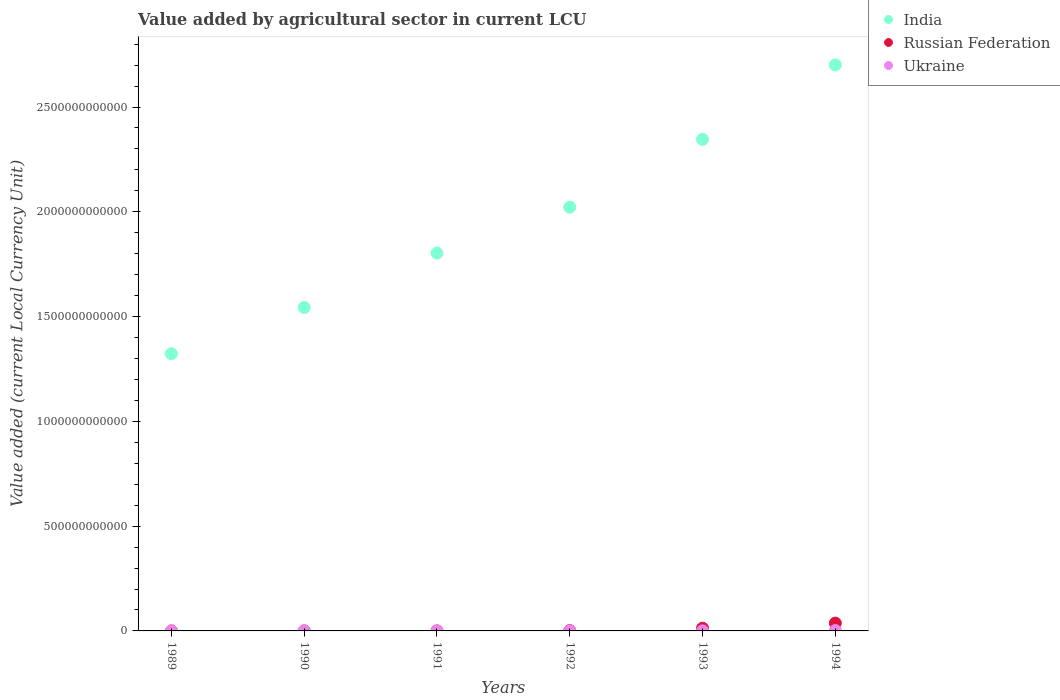Is the number of dotlines equal to the number of legend labels?
Provide a short and direct response. Yes. What is the value added by agricultural sector in Ukraine in 1994?
Give a very brief answer. 1.75e+09. Across all years, what is the maximum value added by agricultural sector in Ukraine?
Make the answer very short. 1.75e+09. Across all years, what is the minimum value added by agricultural sector in India?
Make the answer very short. 1.32e+12. In which year was the value added by agricultural sector in India minimum?
Give a very brief answer. 1989. What is the total value added by agricultural sector in Ukraine in the graph?
Your answer should be compact. 2.09e+09. What is the difference between the value added by agricultural sector in Ukraine in 1991 and that in 1992?
Give a very brief answer. -9.76e+06. What is the difference between the value added by agricultural sector in India in 1991 and the value added by agricultural sector in Ukraine in 1992?
Provide a short and direct response. 1.80e+12. What is the average value added by agricultural sector in Russian Federation per year?
Make the answer very short. 8.67e+09. In the year 1994, what is the difference between the value added by agricultural sector in Ukraine and value added by agricultural sector in India?
Give a very brief answer. -2.70e+12. In how many years, is the value added by agricultural sector in India greater than 1800000000000 LCU?
Your answer should be compact. 4. What is the ratio of the value added by agricultural sector in India in 1992 to that in 1994?
Make the answer very short. 0.75. Is the value added by agricultural sector in Ukraine in 1990 less than that in 1991?
Your response must be concise. Yes. What is the difference between the highest and the second highest value added by agricultural sector in Russian Federation?
Provide a succinct answer. 2.44e+1. What is the difference between the highest and the lowest value added by agricultural sector in India?
Your answer should be compact. 1.38e+12. Is it the case that in every year, the sum of the value added by agricultural sector in Ukraine and value added by agricultural sector in India  is greater than the value added by agricultural sector in Russian Federation?
Give a very brief answer. Yes. Does the value added by agricultural sector in Ukraine monotonically increase over the years?
Provide a succinct answer. Yes. How many years are there in the graph?
Ensure brevity in your answer.  6. What is the difference between two consecutive major ticks on the Y-axis?
Provide a short and direct response. 5.00e+11. Does the graph contain any zero values?
Your answer should be compact. No. Where does the legend appear in the graph?
Ensure brevity in your answer.  Top right. How are the legend labels stacked?
Make the answer very short. Vertical. What is the title of the graph?
Give a very brief answer. Value added by agricultural sector in current LCU. Does "Italy" appear as one of the legend labels in the graph?
Keep it short and to the point. No. What is the label or title of the X-axis?
Offer a very short reply. Years. What is the label or title of the Y-axis?
Keep it short and to the point. Value added (current Local Currency Unit). What is the Value added (current Local Currency Unit) in India in 1989?
Offer a terse response. 1.32e+12. What is the Value added (current Local Currency Unit) of Russian Federation in 1989?
Give a very brief answer. 8.94e+07. What is the Value added (current Local Currency Unit) of Ukraine in 1989?
Offer a terse response. 3.42e+05. What is the Value added (current Local Currency Unit) in India in 1990?
Your response must be concise. 1.54e+12. What is the Value added (current Local Currency Unit) in Russian Federation in 1990?
Offer a very short reply. 9.96e+07. What is the Value added (current Local Currency Unit) of Ukraine in 1990?
Offer a terse response. 4.09e+05. What is the Value added (current Local Currency Unit) in India in 1991?
Offer a terse response. 1.80e+12. What is the Value added (current Local Currency Unit) of Russian Federation in 1991?
Ensure brevity in your answer.  1.93e+08. What is the Value added (current Local Currency Unit) of Ukraine in 1991?
Your answer should be very brief. 7.37e+05. What is the Value added (current Local Currency Unit) of India in 1992?
Your response must be concise. 2.02e+12. What is the Value added (current Local Currency Unit) of Russian Federation in 1992?
Provide a short and direct response. 1.38e+09. What is the Value added (current Local Currency Unit) in Ukraine in 1992?
Make the answer very short. 1.05e+07. What is the Value added (current Local Currency Unit) of India in 1993?
Keep it short and to the point. 2.35e+12. What is the Value added (current Local Currency Unit) of Russian Federation in 1993?
Provide a succinct answer. 1.30e+1. What is the Value added (current Local Currency Unit) of Ukraine in 1993?
Your answer should be compact. 3.19e+08. What is the Value added (current Local Currency Unit) of India in 1994?
Make the answer very short. 2.70e+12. What is the Value added (current Local Currency Unit) of Russian Federation in 1994?
Offer a terse response. 3.73e+1. What is the Value added (current Local Currency Unit) in Ukraine in 1994?
Make the answer very short. 1.75e+09. Across all years, what is the maximum Value added (current Local Currency Unit) of India?
Give a very brief answer. 2.70e+12. Across all years, what is the maximum Value added (current Local Currency Unit) of Russian Federation?
Offer a terse response. 3.73e+1. Across all years, what is the maximum Value added (current Local Currency Unit) of Ukraine?
Your answer should be very brief. 1.75e+09. Across all years, what is the minimum Value added (current Local Currency Unit) in India?
Your response must be concise. 1.32e+12. Across all years, what is the minimum Value added (current Local Currency Unit) of Russian Federation?
Offer a very short reply. 8.94e+07. Across all years, what is the minimum Value added (current Local Currency Unit) in Ukraine?
Provide a succinct answer. 3.42e+05. What is the total Value added (current Local Currency Unit) of India in the graph?
Your answer should be very brief. 1.17e+13. What is the total Value added (current Local Currency Unit) of Russian Federation in the graph?
Offer a terse response. 5.20e+1. What is the total Value added (current Local Currency Unit) of Ukraine in the graph?
Your answer should be compact. 2.09e+09. What is the difference between the Value added (current Local Currency Unit) of India in 1989 and that in 1990?
Provide a succinct answer. -2.21e+11. What is the difference between the Value added (current Local Currency Unit) in Russian Federation in 1989 and that in 1990?
Your answer should be very brief. -1.02e+07. What is the difference between the Value added (current Local Currency Unit) in Ukraine in 1989 and that in 1990?
Make the answer very short. -6.71e+04. What is the difference between the Value added (current Local Currency Unit) of India in 1989 and that in 1991?
Make the answer very short. -4.80e+11. What is the difference between the Value added (current Local Currency Unit) of Russian Federation in 1989 and that in 1991?
Ensure brevity in your answer.  -1.03e+08. What is the difference between the Value added (current Local Currency Unit) in Ukraine in 1989 and that in 1991?
Provide a short and direct response. -3.96e+05. What is the difference between the Value added (current Local Currency Unit) of India in 1989 and that in 1992?
Keep it short and to the point. -7.00e+11. What is the difference between the Value added (current Local Currency Unit) of Russian Federation in 1989 and that in 1992?
Provide a short and direct response. -1.29e+09. What is the difference between the Value added (current Local Currency Unit) in Ukraine in 1989 and that in 1992?
Provide a succinct answer. -1.02e+07. What is the difference between the Value added (current Local Currency Unit) of India in 1989 and that in 1993?
Make the answer very short. -1.02e+12. What is the difference between the Value added (current Local Currency Unit) in Russian Federation in 1989 and that in 1993?
Make the answer very short. -1.29e+1. What is the difference between the Value added (current Local Currency Unit) in Ukraine in 1989 and that in 1993?
Provide a succinct answer. -3.19e+08. What is the difference between the Value added (current Local Currency Unit) of India in 1989 and that in 1994?
Provide a short and direct response. -1.38e+12. What is the difference between the Value added (current Local Currency Unit) in Russian Federation in 1989 and that in 1994?
Your answer should be compact. -3.72e+1. What is the difference between the Value added (current Local Currency Unit) in Ukraine in 1989 and that in 1994?
Your answer should be very brief. -1.75e+09. What is the difference between the Value added (current Local Currency Unit) in India in 1990 and that in 1991?
Provide a succinct answer. -2.60e+11. What is the difference between the Value added (current Local Currency Unit) of Russian Federation in 1990 and that in 1991?
Make the answer very short. -9.30e+07. What is the difference between the Value added (current Local Currency Unit) in Ukraine in 1990 and that in 1991?
Ensure brevity in your answer.  -3.28e+05. What is the difference between the Value added (current Local Currency Unit) of India in 1990 and that in 1992?
Your answer should be compact. -4.79e+11. What is the difference between the Value added (current Local Currency Unit) in Russian Federation in 1990 and that in 1992?
Make the answer very short. -1.28e+09. What is the difference between the Value added (current Local Currency Unit) of Ukraine in 1990 and that in 1992?
Give a very brief answer. -1.01e+07. What is the difference between the Value added (current Local Currency Unit) in India in 1990 and that in 1993?
Ensure brevity in your answer.  -8.02e+11. What is the difference between the Value added (current Local Currency Unit) of Russian Federation in 1990 and that in 1993?
Your answer should be very brief. -1.29e+1. What is the difference between the Value added (current Local Currency Unit) of Ukraine in 1990 and that in 1993?
Keep it short and to the point. -3.19e+08. What is the difference between the Value added (current Local Currency Unit) in India in 1990 and that in 1994?
Offer a terse response. -1.16e+12. What is the difference between the Value added (current Local Currency Unit) of Russian Federation in 1990 and that in 1994?
Keep it short and to the point. -3.72e+1. What is the difference between the Value added (current Local Currency Unit) of Ukraine in 1990 and that in 1994?
Your answer should be very brief. -1.75e+09. What is the difference between the Value added (current Local Currency Unit) in India in 1991 and that in 1992?
Your answer should be very brief. -2.19e+11. What is the difference between the Value added (current Local Currency Unit) of Russian Federation in 1991 and that in 1992?
Your response must be concise. -1.19e+09. What is the difference between the Value added (current Local Currency Unit) of Ukraine in 1991 and that in 1992?
Provide a short and direct response. -9.76e+06. What is the difference between the Value added (current Local Currency Unit) in India in 1991 and that in 1993?
Give a very brief answer. -5.43e+11. What is the difference between the Value added (current Local Currency Unit) in Russian Federation in 1991 and that in 1993?
Your response must be concise. -1.28e+1. What is the difference between the Value added (current Local Currency Unit) of Ukraine in 1991 and that in 1993?
Ensure brevity in your answer.  -3.19e+08. What is the difference between the Value added (current Local Currency Unit) of India in 1991 and that in 1994?
Your answer should be very brief. -8.98e+11. What is the difference between the Value added (current Local Currency Unit) in Russian Federation in 1991 and that in 1994?
Provide a succinct answer. -3.71e+1. What is the difference between the Value added (current Local Currency Unit) in Ukraine in 1991 and that in 1994?
Your response must be concise. -1.75e+09. What is the difference between the Value added (current Local Currency Unit) of India in 1992 and that in 1993?
Make the answer very short. -3.23e+11. What is the difference between the Value added (current Local Currency Unit) in Russian Federation in 1992 and that in 1993?
Provide a short and direct response. -1.16e+1. What is the difference between the Value added (current Local Currency Unit) of Ukraine in 1992 and that in 1993?
Offer a terse response. -3.09e+08. What is the difference between the Value added (current Local Currency Unit) of India in 1992 and that in 1994?
Make the answer very short. -6.79e+11. What is the difference between the Value added (current Local Currency Unit) of Russian Federation in 1992 and that in 1994?
Provide a short and direct response. -3.59e+1. What is the difference between the Value added (current Local Currency Unit) of Ukraine in 1992 and that in 1994?
Your response must be concise. -1.74e+09. What is the difference between the Value added (current Local Currency Unit) in India in 1993 and that in 1994?
Offer a very short reply. -3.55e+11. What is the difference between the Value added (current Local Currency Unit) of Russian Federation in 1993 and that in 1994?
Provide a short and direct response. -2.44e+1. What is the difference between the Value added (current Local Currency Unit) in Ukraine in 1993 and that in 1994?
Offer a very short reply. -1.43e+09. What is the difference between the Value added (current Local Currency Unit) of India in 1989 and the Value added (current Local Currency Unit) of Russian Federation in 1990?
Keep it short and to the point. 1.32e+12. What is the difference between the Value added (current Local Currency Unit) of India in 1989 and the Value added (current Local Currency Unit) of Ukraine in 1990?
Make the answer very short. 1.32e+12. What is the difference between the Value added (current Local Currency Unit) of Russian Federation in 1989 and the Value added (current Local Currency Unit) of Ukraine in 1990?
Your answer should be very brief. 8.90e+07. What is the difference between the Value added (current Local Currency Unit) of India in 1989 and the Value added (current Local Currency Unit) of Russian Federation in 1991?
Give a very brief answer. 1.32e+12. What is the difference between the Value added (current Local Currency Unit) in India in 1989 and the Value added (current Local Currency Unit) in Ukraine in 1991?
Provide a short and direct response. 1.32e+12. What is the difference between the Value added (current Local Currency Unit) of Russian Federation in 1989 and the Value added (current Local Currency Unit) of Ukraine in 1991?
Make the answer very short. 8.87e+07. What is the difference between the Value added (current Local Currency Unit) in India in 1989 and the Value added (current Local Currency Unit) in Russian Federation in 1992?
Provide a succinct answer. 1.32e+12. What is the difference between the Value added (current Local Currency Unit) of India in 1989 and the Value added (current Local Currency Unit) of Ukraine in 1992?
Your answer should be compact. 1.32e+12. What is the difference between the Value added (current Local Currency Unit) in Russian Federation in 1989 and the Value added (current Local Currency Unit) in Ukraine in 1992?
Offer a very short reply. 7.89e+07. What is the difference between the Value added (current Local Currency Unit) of India in 1989 and the Value added (current Local Currency Unit) of Russian Federation in 1993?
Your answer should be compact. 1.31e+12. What is the difference between the Value added (current Local Currency Unit) in India in 1989 and the Value added (current Local Currency Unit) in Ukraine in 1993?
Your response must be concise. 1.32e+12. What is the difference between the Value added (current Local Currency Unit) of Russian Federation in 1989 and the Value added (current Local Currency Unit) of Ukraine in 1993?
Provide a short and direct response. -2.30e+08. What is the difference between the Value added (current Local Currency Unit) in India in 1989 and the Value added (current Local Currency Unit) in Russian Federation in 1994?
Keep it short and to the point. 1.29e+12. What is the difference between the Value added (current Local Currency Unit) of India in 1989 and the Value added (current Local Currency Unit) of Ukraine in 1994?
Your answer should be compact. 1.32e+12. What is the difference between the Value added (current Local Currency Unit) of Russian Federation in 1989 and the Value added (current Local Currency Unit) of Ukraine in 1994?
Keep it short and to the point. -1.66e+09. What is the difference between the Value added (current Local Currency Unit) in India in 1990 and the Value added (current Local Currency Unit) in Russian Federation in 1991?
Offer a terse response. 1.54e+12. What is the difference between the Value added (current Local Currency Unit) in India in 1990 and the Value added (current Local Currency Unit) in Ukraine in 1991?
Offer a very short reply. 1.54e+12. What is the difference between the Value added (current Local Currency Unit) in Russian Federation in 1990 and the Value added (current Local Currency Unit) in Ukraine in 1991?
Offer a very short reply. 9.89e+07. What is the difference between the Value added (current Local Currency Unit) in India in 1990 and the Value added (current Local Currency Unit) in Russian Federation in 1992?
Provide a short and direct response. 1.54e+12. What is the difference between the Value added (current Local Currency Unit) in India in 1990 and the Value added (current Local Currency Unit) in Ukraine in 1992?
Offer a terse response. 1.54e+12. What is the difference between the Value added (current Local Currency Unit) of Russian Federation in 1990 and the Value added (current Local Currency Unit) of Ukraine in 1992?
Offer a terse response. 8.91e+07. What is the difference between the Value added (current Local Currency Unit) of India in 1990 and the Value added (current Local Currency Unit) of Russian Federation in 1993?
Your answer should be very brief. 1.53e+12. What is the difference between the Value added (current Local Currency Unit) of India in 1990 and the Value added (current Local Currency Unit) of Ukraine in 1993?
Keep it short and to the point. 1.54e+12. What is the difference between the Value added (current Local Currency Unit) in Russian Federation in 1990 and the Value added (current Local Currency Unit) in Ukraine in 1993?
Offer a terse response. -2.20e+08. What is the difference between the Value added (current Local Currency Unit) of India in 1990 and the Value added (current Local Currency Unit) of Russian Federation in 1994?
Offer a very short reply. 1.51e+12. What is the difference between the Value added (current Local Currency Unit) in India in 1990 and the Value added (current Local Currency Unit) in Ukraine in 1994?
Give a very brief answer. 1.54e+12. What is the difference between the Value added (current Local Currency Unit) in Russian Federation in 1990 and the Value added (current Local Currency Unit) in Ukraine in 1994?
Your answer should be very brief. -1.65e+09. What is the difference between the Value added (current Local Currency Unit) in India in 1991 and the Value added (current Local Currency Unit) in Russian Federation in 1992?
Your response must be concise. 1.80e+12. What is the difference between the Value added (current Local Currency Unit) of India in 1991 and the Value added (current Local Currency Unit) of Ukraine in 1992?
Provide a short and direct response. 1.80e+12. What is the difference between the Value added (current Local Currency Unit) of Russian Federation in 1991 and the Value added (current Local Currency Unit) of Ukraine in 1992?
Provide a short and direct response. 1.82e+08. What is the difference between the Value added (current Local Currency Unit) of India in 1991 and the Value added (current Local Currency Unit) of Russian Federation in 1993?
Ensure brevity in your answer.  1.79e+12. What is the difference between the Value added (current Local Currency Unit) of India in 1991 and the Value added (current Local Currency Unit) of Ukraine in 1993?
Make the answer very short. 1.80e+12. What is the difference between the Value added (current Local Currency Unit) of Russian Federation in 1991 and the Value added (current Local Currency Unit) of Ukraine in 1993?
Your answer should be very brief. -1.27e+08. What is the difference between the Value added (current Local Currency Unit) of India in 1991 and the Value added (current Local Currency Unit) of Russian Federation in 1994?
Give a very brief answer. 1.77e+12. What is the difference between the Value added (current Local Currency Unit) in India in 1991 and the Value added (current Local Currency Unit) in Ukraine in 1994?
Provide a succinct answer. 1.80e+12. What is the difference between the Value added (current Local Currency Unit) in Russian Federation in 1991 and the Value added (current Local Currency Unit) in Ukraine in 1994?
Make the answer very short. -1.56e+09. What is the difference between the Value added (current Local Currency Unit) of India in 1992 and the Value added (current Local Currency Unit) of Russian Federation in 1993?
Make the answer very short. 2.01e+12. What is the difference between the Value added (current Local Currency Unit) in India in 1992 and the Value added (current Local Currency Unit) in Ukraine in 1993?
Provide a succinct answer. 2.02e+12. What is the difference between the Value added (current Local Currency Unit) of Russian Federation in 1992 and the Value added (current Local Currency Unit) of Ukraine in 1993?
Keep it short and to the point. 1.06e+09. What is the difference between the Value added (current Local Currency Unit) of India in 1992 and the Value added (current Local Currency Unit) of Russian Federation in 1994?
Ensure brevity in your answer.  1.98e+12. What is the difference between the Value added (current Local Currency Unit) in India in 1992 and the Value added (current Local Currency Unit) in Ukraine in 1994?
Your response must be concise. 2.02e+12. What is the difference between the Value added (current Local Currency Unit) of Russian Federation in 1992 and the Value added (current Local Currency Unit) of Ukraine in 1994?
Your response must be concise. -3.73e+08. What is the difference between the Value added (current Local Currency Unit) of India in 1993 and the Value added (current Local Currency Unit) of Russian Federation in 1994?
Ensure brevity in your answer.  2.31e+12. What is the difference between the Value added (current Local Currency Unit) of India in 1993 and the Value added (current Local Currency Unit) of Ukraine in 1994?
Your response must be concise. 2.34e+12. What is the difference between the Value added (current Local Currency Unit) of Russian Federation in 1993 and the Value added (current Local Currency Unit) of Ukraine in 1994?
Offer a terse response. 1.12e+1. What is the average Value added (current Local Currency Unit) in India per year?
Your answer should be compact. 1.96e+12. What is the average Value added (current Local Currency Unit) in Russian Federation per year?
Keep it short and to the point. 8.67e+09. What is the average Value added (current Local Currency Unit) of Ukraine per year?
Offer a very short reply. 3.48e+08. In the year 1989, what is the difference between the Value added (current Local Currency Unit) of India and Value added (current Local Currency Unit) of Russian Federation?
Offer a very short reply. 1.32e+12. In the year 1989, what is the difference between the Value added (current Local Currency Unit) of India and Value added (current Local Currency Unit) of Ukraine?
Your answer should be very brief. 1.32e+12. In the year 1989, what is the difference between the Value added (current Local Currency Unit) in Russian Federation and Value added (current Local Currency Unit) in Ukraine?
Your answer should be compact. 8.91e+07. In the year 1990, what is the difference between the Value added (current Local Currency Unit) of India and Value added (current Local Currency Unit) of Russian Federation?
Give a very brief answer. 1.54e+12. In the year 1990, what is the difference between the Value added (current Local Currency Unit) in India and Value added (current Local Currency Unit) in Ukraine?
Offer a terse response. 1.54e+12. In the year 1990, what is the difference between the Value added (current Local Currency Unit) of Russian Federation and Value added (current Local Currency Unit) of Ukraine?
Make the answer very short. 9.92e+07. In the year 1991, what is the difference between the Value added (current Local Currency Unit) of India and Value added (current Local Currency Unit) of Russian Federation?
Your answer should be compact. 1.80e+12. In the year 1991, what is the difference between the Value added (current Local Currency Unit) in India and Value added (current Local Currency Unit) in Ukraine?
Offer a very short reply. 1.80e+12. In the year 1991, what is the difference between the Value added (current Local Currency Unit) of Russian Federation and Value added (current Local Currency Unit) of Ukraine?
Offer a very short reply. 1.92e+08. In the year 1992, what is the difference between the Value added (current Local Currency Unit) in India and Value added (current Local Currency Unit) in Russian Federation?
Provide a short and direct response. 2.02e+12. In the year 1992, what is the difference between the Value added (current Local Currency Unit) of India and Value added (current Local Currency Unit) of Ukraine?
Your answer should be compact. 2.02e+12. In the year 1992, what is the difference between the Value added (current Local Currency Unit) of Russian Federation and Value added (current Local Currency Unit) of Ukraine?
Offer a terse response. 1.37e+09. In the year 1993, what is the difference between the Value added (current Local Currency Unit) in India and Value added (current Local Currency Unit) in Russian Federation?
Offer a terse response. 2.33e+12. In the year 1993, what is the difference between the Value added (current Local Currency Unit) in India and Value added (current Local Currency Unit) in Ukraine?
Your response must be concise. 2.35e+12. In the year 1993, what is the difference between the Value added (current Local Currency Unit) in Russian Federation and Value added (current Local Currency Unit) in Ukraine?
Your response must be concise. 1.26e+1. In the year 1994, what is the difference between the Value added (current Local Currency Unit) of India and Value added (current Local Currency Unit) of Russian Federation?
Offer a very short reply. 2.66e+12. In the year 1994, what is the difference between the Value added (current Local Currency Unit) in India and Value added (current Local Currency Unit) in Ukraine?
Your answer should be very brief. 2.70e+12. In the year 1994, what is the difference between the Value added (current Local Currency Unit) in Russian Federation and Value added (current Local Currency Unit) in Ukraine?
Make the answer very short. 3.56e+1. What is the ratio of the Value added (current Local Currency Unit) of India in 1989 to that in 1990?
Offer a very short reply. 0.86. What is the ratio of the Value added (current Local Currency Unit) in Russian Federation in 1989 to that in 1990?
Provide a succinct answer. 0.9. What is the ratio of the Value added (current Local Currency Unit) of Ukraine in 1989 to that in 1990?
Provide a succinct answer. 0.84. What is the ratio of the Value added (current Local Currency Unit) in India in 1989 to that in 1991?
Your response must be concise. 0.73. What is the ratio of the Value added (current Local Currency Unit) of Russian Federation in 1989 to that in 1991?
Make the answer very short. 0.46. What is the ratio of the Value added (current Local Currency Unit) in Ukraine in 1989 to that in 1991?
Provide a succinct answer. 0.46. What is the ratio of the Value added (current Local Currency Unit) of India in 1989 to that in 1992?
Your answer should be very brief. 0.65. What is the ratio of the Value added (current Local Currency Unit) in Russian Federation in 1989 to that in 1992?
Ensure brevity in your answer.  0.06. What is the ratio of the Value added (current Local Currency Unit) in Ukraine in 1989 to that in 1992?
Your response must be concise. 0.03. What is the ratio of the Value added (current Local Currency Unit) in India in 1989 to that in 1993?
Keep it short and to the point. 0.56. What is the ratio of the Value added (current Local Currency Unit) in Russian Federation in 1989 to that in 1993?
Your answer should be very brief. 0.01. What is the ratio of the Value added (current Local Currency Unit) in Ukraine in 1989 to that in 1993?
Ensure brevity in your answer.  0. What is the ratio of the Value added (current Local Currency Unit) in India in 1989 to that in 1994?
Your response must be concise. 0.49. What is the ratio of the Value added (current Local Currency Unit) in Russian Federation in 1989 to that in 1994?
Provide a short and direct response. 0. What is the ratio of the Value added (current Local Currency Unit) in India in 1990 to that in 1991?
Provide a succinct answer. 0.86. What is the ratio of the Value added (current Local Currency Unit) of Russian Federation in 1990 to that in 1991?
Your response must be concise. 0.52. What is the ratio of the Value added (current Local Currency Unit) of Ukraine in 1990 to that in 1991?
Your response must be concise. 0.55. What is the ratio of the Value added (current Local Currency Unit) in India in 1990 to that in 1992?
Keep it short and to the point. 0.76. What is the ratio of the Value added (current Local Currency Unit) of Russian Federation in 1990 to that in 1992?
Ensure brevity in your answer.  0.07. What is the ratio of the Value added (current Local Currency Unit) in Ukraine in 1990 to that in 1992?
Ensure brevity in your answer.  0.04. What is the ratio of the Value added (current Local Currency Unit) in India in 1990 to that in 1993?
Your response must be concise. 0.66. What is the ratio of the Value added (current Local Currency Unit) of Russian Federation in 1990 to that in 1993?
Your answer should be very brief. 0.01. What is the ratio of the Value added (current Local Currency Unit) of Ukraine in 1990 to that in 1993?
Make the answer very short. 0. What is the ratio of the Value added (current Local Currency Unit) of India in 1990 to that in 1994?
Your answer should be compact. 0.57. What is the ratio of the Value added (current Local Currency Unit) of Russian Federation in 1990 to that in 1994?
Give a very brief answer. 0. What is the ratio of the Value added (current Local Currency Unit) in Ukraine in 1990 to that in 1994?
Provide a short and direct response. 0. What is the ratio of the Value added (current Local Currency Unit) in India in 1991 to that in 1992?
Your response must be concise. 0.89. What is the ratio of the Value added (current Local Currency Unit) in Russian Federation in 1991 to that in 1992?
Your response must be concise. 0.14. What is the ratio of the Value added (current Local Currency Unit) in Ukraine in 1991 to that in 1992?
Provide a succinct answer. 0.07. What is the ratio of the Value added (current Local Currency Unit) in India in 1991 to that in 1993?
Your answer should be compact. 0.77. What is the ratio of the Value added (current Local Currency Unit) in Russian Federation in 1991 to that in 1993?
Your response must be concise. 0.01. What is the ratio of the Value added (current Local Currency Unit) in Ukraine in 1991 to that in 1993?
Offer a very short reply. 0. What is the ratio of the Value added (current Local Currency Unit) in India in 1991 to that in 1994?
Keep it short and to the point. 0.67. What is the ratio of the Value added (current Local Currency Unit) in Russian Federation in 1991 to that in 1994?
Make the answer very short. 0.01. What is the ratio of the Value added (current Local Currency Unit) in India in 1992 to that in 1993?
Provide a short and direct response. 0.86. What is the ratio of the Value added (current Local Currency Unit) in Russian Federation in 1992 to that in 1993?
Offer a very short reply. 0.11. What is the ratio of the Value added (current Local Currency Unit) of Ukraine in 1992 to that in 1993?
Your answer should be compact. 0.03. What is the ratio of the Value added (current Local Currency Unit) in India in 1992 to that in 1994?
Make the answer very short. 0.75. What is the ratio of the Value added (current Local Currency Unit) of Russian Federation in 1992 to that in 1994?
Your answer should be very brief. 0.04. What is the ratio of the Value added (current Local Currency Unit) in Ukraine in 1992 to that in 1994?
Your response must be concise. 0.01. What is the ratio of the Value added (current Local Currency Unit) of India in 1993 to that in 1994?
Offer a terse response. 0.87. What is the ratio of the Value added (current Local Currency Unit) in Russian Federation in 1993 to that in 1994?
Offer a very short reply. 0.35. What is the ratio of the Value added (current Local Currency Unit) in Ukraine in 1993 to that in 1994?
Provide a short and direct response. 0.18. What is the difference between the highest and the second highest Value added (current Local Currency Unit) in India?
Ensure brevity in your answer.  3.55e+11. What is the difference between the highest and the second highest Value added (current Local Currency Unit) in Russian Federation?
Your answer should be very brief. 2.44e+1. What is the difference between the highest and the second highest Value added (current Local Currency Unit) in Ukraine?
Your response must be concise. 1.43e+09. What is the difference between the highest and the lowest Value added (current Local Currency Unit) of India?
Make the answer very short. 1.38e+12. What is the difference between the highest and the lowest Value added (current Local Currency Unit) of Russian Federation?
Give a very brief answer. 3.72e+1. What is the difference between the highest and the lowest Value added (current Local Currency Unit) of Ukraine?
Offer a terse response. 1.75e+09. 